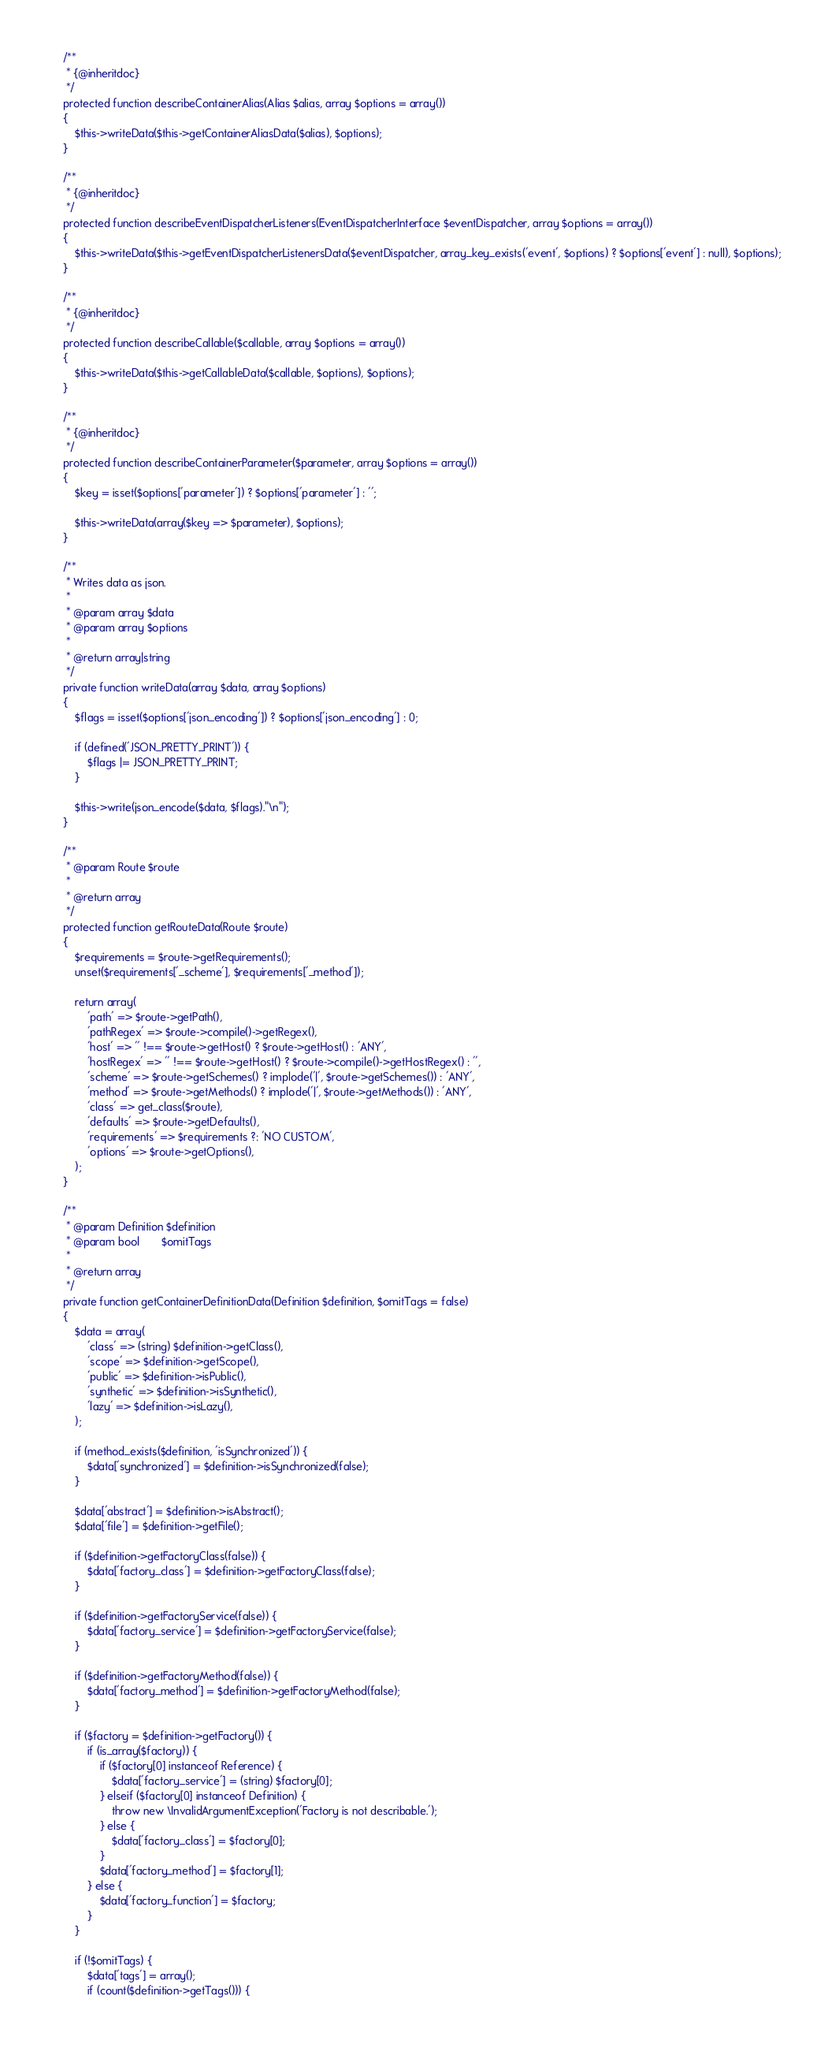<code> <loc_0><loc_0><loc_500><loc_500><_PHP_>    /**
     * {@inheritdoc}
     */
    protected function describeContainerAlias(Alias $alias, array $options = array())
    {
        $this->writeData($this->getContainerAliasData($alias), $options);
    }

    /**
     * {@inheritdoc}
     */
    protected function describeEventDispatcherListeners(EventDispatcherInterface $eventDispatcher, array $options = array())
    {
        $this->writeData($this->getEventDispatcherListenersData($eventDispatcher, array_key_exists('event', $options) ? $options['event'] : null), $options);
    }

    /**
     * {@inheritdoc}
     */
    protected function describeCallable($callable, array $options = array())
    {
        $this->writeData($this->getCallableData($callable, $options), $options);
    }

    /**
     * {@inheritdoc}
     */
    protected function describeContainerParameter($parameter, array $options = array())
    {
        $key = isset($options['parameter']) ? $options['parameter'] : '';

        $this->writeData(array($key => $parameter), $options);
    }

    /**
     * Writes data as json.
     *
     * @param array $data
     * @param array $options
     *
     * @return array|string
     */
    private function writeData(array $data, array $options)
    {
        $flags = isset($options['json_encoding']) ? $options['json_encoding'] : 0;

        if (defined('JSON_PRETTY_PRINT')) {
            $flags |= JSON_PRETTY_PRINT;
        }

        $this->write(json_encode($data, $flags)."\n");
    }

    /**
     * @param Route $route
     *
     * @return array
     */
    protected function getRouteData(Route $route)
    {
        $requirements = $route->getRequirements();
        unset($requirements['_scheme'], $requirements['_method']);

        return array(
            'path' => $route->getPath(),
            'pathRegex' => $route->compile()->getRegex(),
            'host' => '' !== $route->getHost() ? $route->getHost() : 'ANY',
            'hostRegex' => '' !== $route->getHost() ? $route->compile()->getHostRegex() : '',
            'scheme' => $route->getSchemes() ? implode('|', $route->getSchemes()) : 'ANY',
            'method' => $route->getMethods() ? implode('|', $route->getMethods()) : 'ANY',
            'class' => get_class($route),
            'defaults' => $route->getDefaults(),
            'requirements' => $requirements ?: 'NO CUSTOM',
            'options' => $route->getOptions(),
        );
    }

    /**
     * @param Definition $definition
     * @param bool       $omitTags
     *
     * @return array
     */
    private function getContainerDefinitionData(Definition $definition, $omitTags = false)
    {
        $data = array(
            'class' => (string) $definition->getClass(),
            'scope' => $definition->getScope(),
            'public' => $definition->isPublic(),
            'synthetic' => $definition->isSynthetic(),
            'lazy' => $definition->isLazy(),
        );

        if (method_exists($definition, 'isSynchronized')) {
            $data['synchronized'] = $definition->isSynchronized(false);
        }

        $data['abstract'] = $definition->isAbstract();
        $data['file'] = $definition->getFile();

        if ($definition->getFactoryClass(false)) {
            $data['factory_class'] = $definition->getFactoryClass(false);
        }

        if ($definition->getFactoryService(false)) {
            $data['factory_service'] = $definition->getFactoryService(false);
        }

        if ($definition->getFactoryMethod(false)) {
            $data['factory_method'] = $definition->getFactoryMethod(false);
        }

        if ($factory = $definition->getFactory()) {
            if (is_array($factory)) {
                if ($factory[0] instanceof Reference) {
                    $data['factory_service'] = (string) $factory[0];
                } elseif ($factory[0] instanceof Definition) {
                    throw new \InvalidArgumentException('Factory is not describable.');
                } else {
                    $data['factory_class'] = $factory[0];
                }
                $data['factory_method'] = $factory[1];
            } else {
                $data['factory_function'] = $factory;
            }
        }

        if (!$omitTags) {
            $data['tags'] = array();
            if (count($definition->getTags())) {</code> 